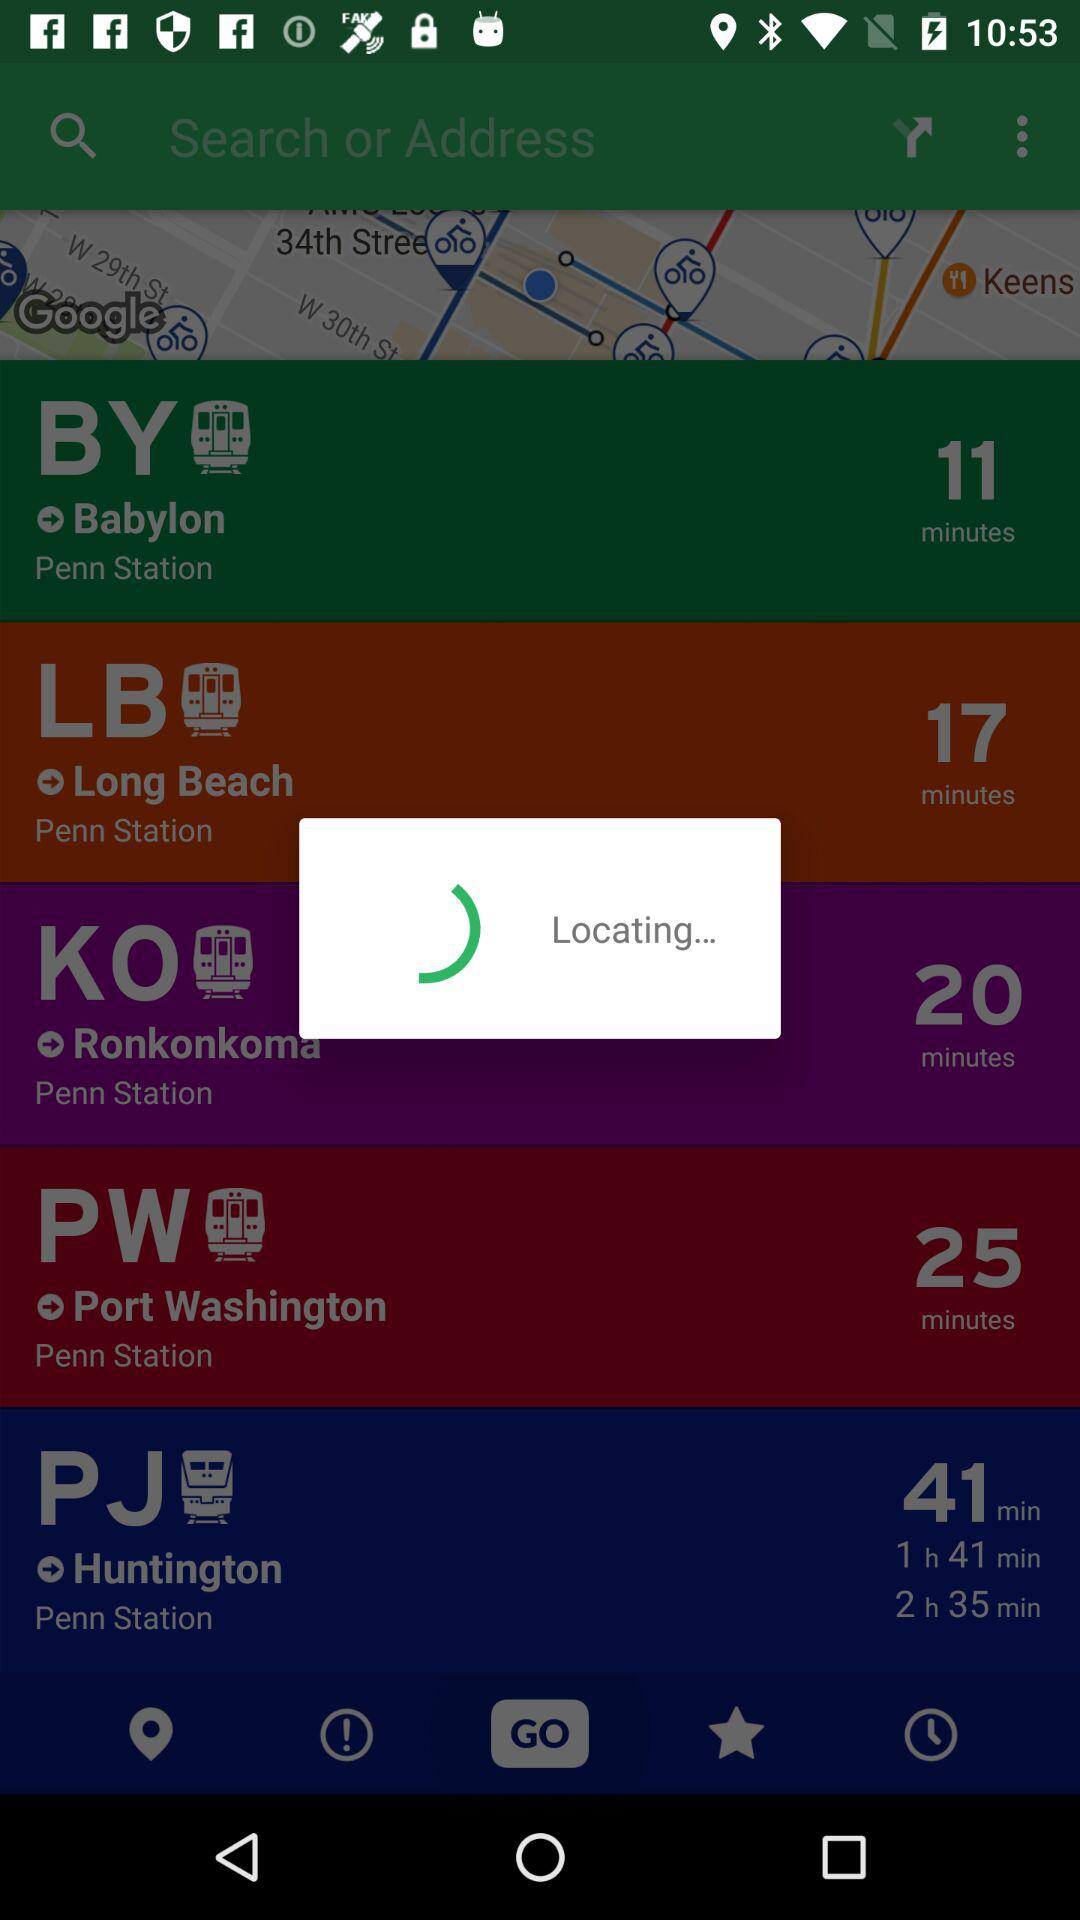How many trains are there in total?
Answer the question using a single word or phrase. 5 